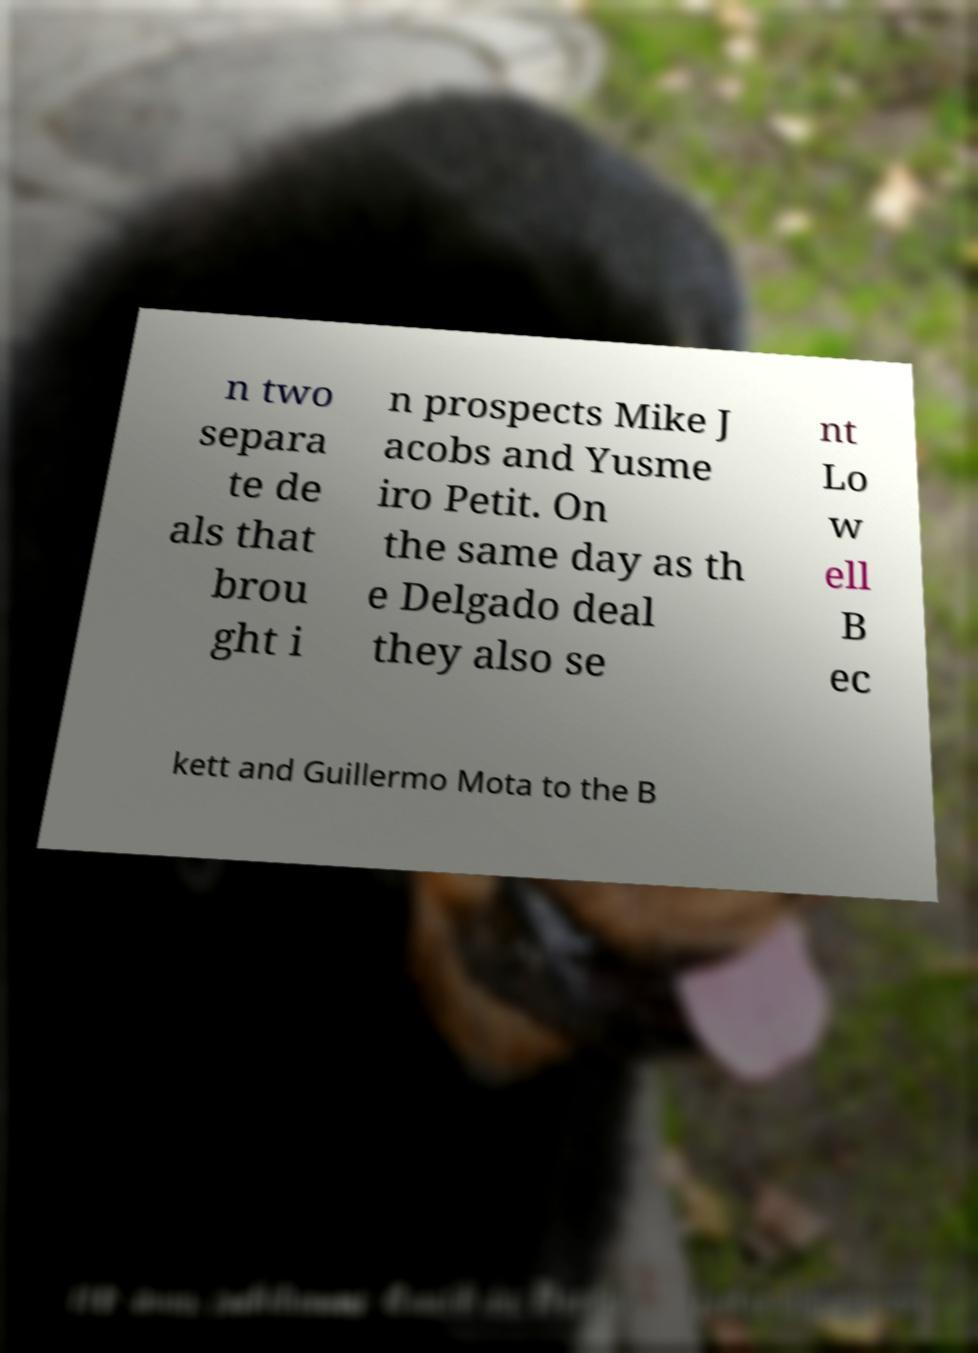For documentation purposes, I need the text within this image transcribed. Could you provide that? n two separa te de als that brou ght i n prospects Mike J acobs and Yusme iro Petit. On the same day as th e Delgado deal they also se nt Lo w ell B ec kett and Guillermo Mota to the B 